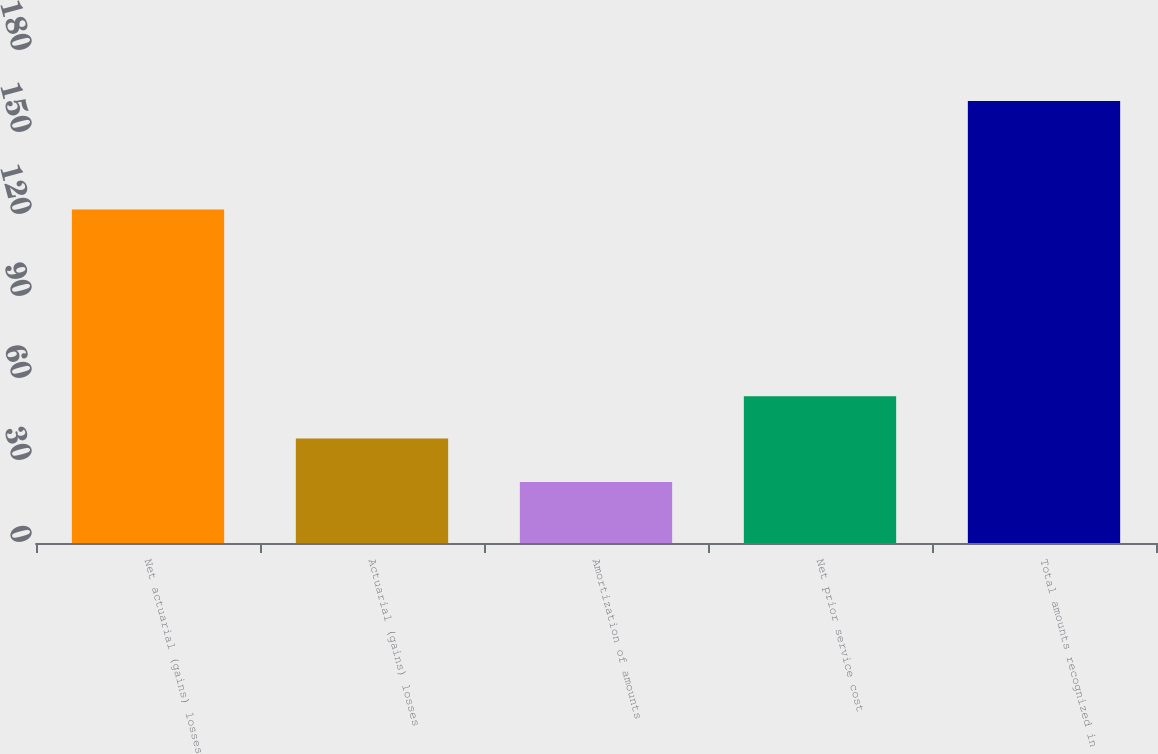Convert chart. <chart><loc_0><loc_0><loc_500><loc_500><bar_chart><fcel>Net actuarial (gains) losses<fcel>Actuarial (gains) losses<fcel>Amortization of amounts<fcel>Net prior service cost<fcel>Total amounts recognized in<nl><fcel>122<fcel>38.2<fcel>22.29<fcel>53.69<fcel>161.7<nl></chart> 